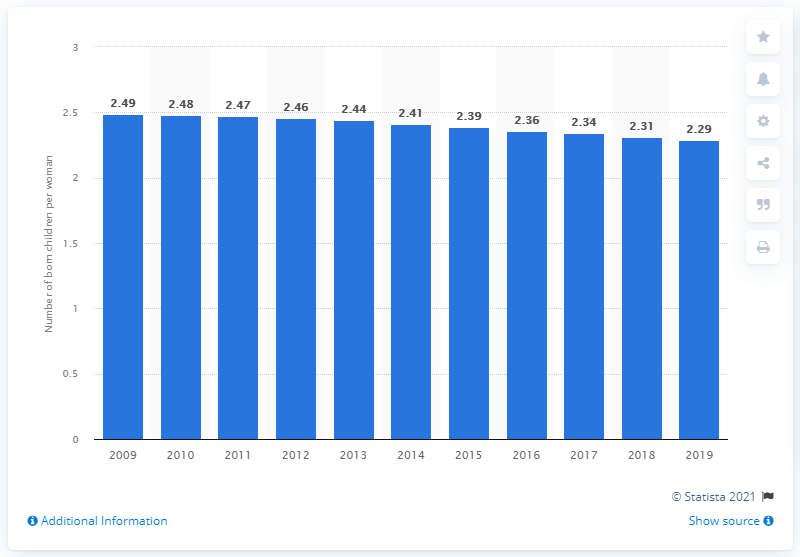Outline some significant characteristics in this image. In 2019, the fertility rate in Indonesia was 2.29. 